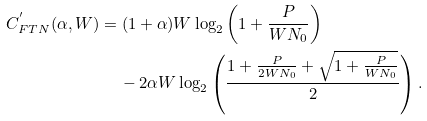<formula> <loc_0><loc_0><loc_500><loc_500>C ^ { ^ { \prime } } _ { F T N } ( \alpha , W ) & = ( 1 + \alpha ) W \log _ { 2 } \left ( 1 + \frac { P } { W N _ { 0 } } \right ) \\ & \quad \, - 2 \alpha W \log _ { 2 } \left ( \frac { 1 + \frac { P } { 2 W N _ { 0 } } + \sqrt { 1 + \frac { P } { W N _ { 0 } } } } { 2 } \right ) . \\</formula> 